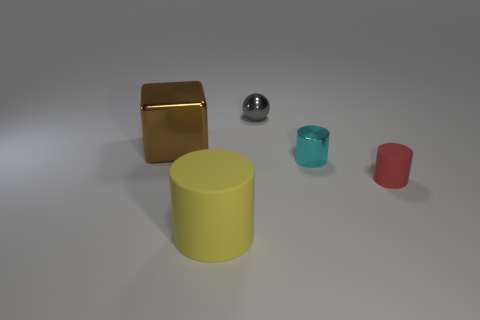Add 4 small green rubber balls. How many small green rubber balls exist? 4 Add 4 yellow matte cylinders. How many objects exist? 9 Subtract all yellow cylinders. How many cylinders are left? 2 Subtract all big yellow rubber cylinders. How many cylinders are left? 2 Subtract 0 green blocks. How many objects are left? 5 Subtract all cylinders. How many objects are left? 2 Subtract 1 spheres. How many spheres are left? 0 Subtract all cyan spheres. Subtract all cyan blocks. How many spheres are left? 1 Subtract all blue spheres. How many yellow cylinders are left? 1 Subtract all large yellow cylinders. Subtract all small gray things. How many objects are left? 3 